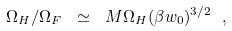<formula> <loc_0><loc_0><loc_500><loc_500>\Omega _ { H } / \Omega _ { F } \ \simeq \ M \Omega _ { H } ( \beta w _ { 0 } ) ^ { 3 / 2 } \ ,</formula> 